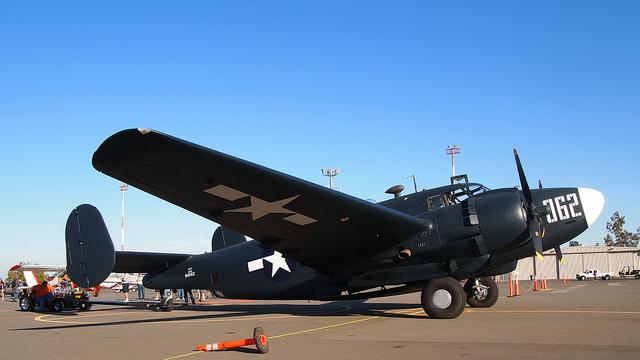What's the number on the closest plane?
Concise answer only. 362. What sort of emblem is under the wing?
Be succinct. Star. What no is on the plane?
Write a very short answer. 362. Have any of the orange bollards fallen over?
Keep it brief. Yes. Is the propeller of the plane missing?
Concise answer only. No. 